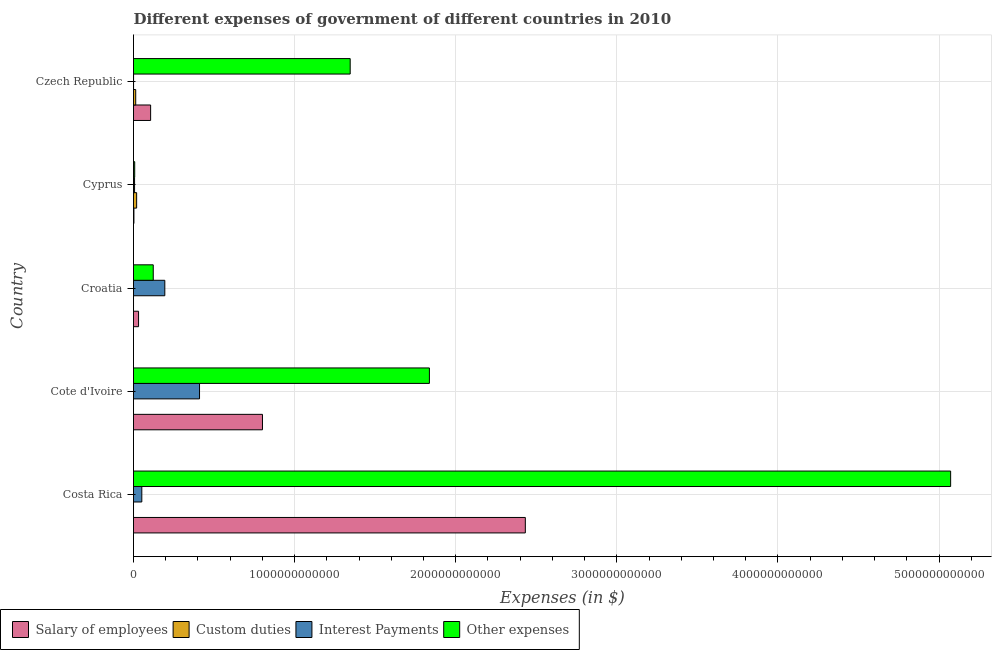How many different coloured bars are there?
Make the answer very short. 4. How many groups of bars are there?
Ensure brevity in your answer.  5. Are the number of bars on each tick of the Y-axis equal?
Give a very brief answer. Yes. How many bars are there on the 2nd tick from the top?
Provide a succinct answer. 4. How many bars are there on the 1st tick from the bottom?
Provide a short and direct response. 4. What is the label of the 4th group of bars from the top?
Provide a succinct answer. Cote d'Ivoire. What is the amount spent on interest payments in Cote d'Ivoire?
Ensure brevity in your answer.  4.10e+11. Across all countries, what is the maximum amount spent on other expenses?
Your answer should be very brief. 5.07e+12. Across all countries, what is the minimum amount spent on salary of employees?
Give a very brief answer. 2.62e+09. In which country was the amount spent on interest payments maximum?
Offer a very short reply. Cote d'Ivoire. In which country was the amount spent on other expenses minimum?
Give a very brief answer. Cyprus. What is the total amount spent on custom duties in the graph?
Your response must be concise. 3.33e+1. What is the difference between the amount spent on custom duties in Cote d'Ivoire and that in Croatia?
Provide a succinct answer. -4.22e+07. What is the difference between the amount spent on salary of employees in Czech Republic and the amount spent on interest payments in Croatia?
Ensure brevity in your answer.  -8.81e+1. What is the average amount spent on salary of employees per country?
Keep it short and to the point. 6.75e+11. What is the difference between the amount spent on custom duties and amount spent on interest payments in Cote d'Ivoire?
Ensure brevity in your answer.  -4.10e+11. What is the ratio of the amount spent on interest payments in Cote d'Ivoire to that in Czech Republic?
Your answer should be compact. 1133.54. Is the difference between the amount spent on custom duties in Cote d'Ivoire and Cyprus greater than the difference between the amount spent on salary of employees in Cote d'Ivoire and Cyprus?
Provide a succinct answer. No. What is the difference between the highest and the second highest amount spent on other expenses?
Make the answer very short. 3.24e+12. What is the difference between the highest and the lowest amount spent on custom duties?
Ensure brevity in your answer.  1.95e+1. In how many countries, is the amount spent on other expenses greater than the average amount spent on other expenses taken over all countries?
Provide a short and direct response. 2. What does the 1st bar from the top in Cyprus represents?
Ensure brevity in your answer.  Other expenses. What does the 2nd bar from the bottom in Czech Republic represents?
Ensure brevity in your answer.  Custom duties. Is it the case that in every country, the sum of the amount spent on salary of employees and amount spent on custom duties is greater than the amount spent on interest payments?
Provide a succinct answer. No. How many bars are there?
Keep it short and to the point. 20. How many countries are there in the graph?
Provide a short and direct response. 5. What is the difference between two consecutive major ticks on the X-axis?
Offer a terse response. 1.00e+12. Does the graph contain any zero values?
Provide a succinct answer. No. Does the graph contain grids?
Keep it short and to the point. Yes. How many legend labels are there?
Offer a terse response. 4. How are the legend labels stacked?
Ensure brevity in your answer.  Horizontal. What is the title of the graph?
Keep it short and to the point. Different expenses of government of different countries in 2010. What is the label or title of the X-axis?
Offer a terse response. Expenses (in $). What is the label or title of the Y-axis?
Your response must be concise. Country. What is the Expenses (in $) in Salary of employees in Costa Rica?
Offer a very short reply. 2.43e+12. What is the Expenses (in $) in Custom duties in Costa Rica?
Make the answer very short. 3.64e+07. What is the Expenses (in $) in Interest Payments in Costa Rica?
Give a very brief answer. 5.15e+1. What is the Expenses (in $) in Other expenses in Costa Rica?
Your answer should be very brief. 5.07e+12. What is the Expenses (in $) in Salary of employees in Cote d'Ivoire?
Offer a very short reply. 8.00e+11. What is the Expenses (in $) in Custom duties in Cote d'Ivoire?
Keep it short and to the point. 1.30e+07. What is the Expenses (in $) in Interest Payments in Cote d'Ivoire?
Provide a succinct answer. 4.10e+11. What is the Expenses (in $) in Other expenses in Cote d'Ivoire?
Give a very brief answer. 1.84e+12. What is the Expenses (in $) of Salary of employees in Croatia?
Provide a succinct answer. 3.14e+1. What is the Expenses (in $) of Custom duties in Croatia?
Your answer should be very brief. 5.52e+07. What is the Expenses (in $) in Interest Payments in Croatia?
Ensure brevity in your answer.  1.94e+11. What is the Expenses (in $) in Other expenses in Croatia?
Offer a very short reply. 1.23e+11. What is the Expenses (in $) in Salary of employees in Cyprus?
Your answer should be compact. 2.62e+09. What is the Expenses (in $) in Custom duties in Cyprus?
Keep it short and to the point. 1.95e+1. What is the Expenses (in $) in Interest Payments in Cyprus?
Provide a succinct answer. 6.55e+09. What is the Expenses (in $) in Other expenses in Cyprus?
Keep it short and to the point. 7.41e+09. What is the Expenses (in $) in Salary of employees in Czech Republic?
Your answer should be very brief. 1.06e+11. What is the Expenses (in $) of Custom duties in Czech Republic?
Keep it short and to the point. 1.37e+1. What is the Expenses (in $) in Interest Payments in Czech Republic?
Ensure brevity in your answer.  3.62e+08. What is the Expenses (in $) of Other expenses in Czech Republic?
Offer a very short reply. 1.34e+12. Across all countries, what is the maximum Expenses (in $) in Salary of employees?
Keep it short and to the point. 2.43e+12. Across all countries, what is the maximum Expenses (in $) of Custom duties?
Your answer should be compact. 1.95e+1. Across all countries, what is the maximum Expenses (in $) of Interest Payments?
Keep it short and to the point. 4.10e+11. Across all countries, what is the maximum Expenses (in $) of Other expenses?
Keep it short and to the point. 5.07e+12. Across all countries, what is the minimum Expenses (in $) in Salary of employees?
Your response must be concise. 2.62e+09. Across all countries, what is the minimum Expenses (in $) in Custom duties?
Offer a terse response. 1.30e+07. Across all countries, what is the minimum Expenses (in $) of Interest Payments?
Your answer should be very brief. 3.62e+08. Across all countries, what is the minimum Expenses (in $) of Other expenses?
Make the answer very short. 7.41e+09. What is the total Expenses (in $) of Salary of employees in the graph?
Give a very brief answer. 3.37e+12. What is the total Expenses (in $) in Custom duties in the graph?
Offer a terse response. 3.33e+1. What is the total Expenses (in $) in Interest Payments in the graph?
Ensure brevity in your answer.  6.63e+11. What is the total Expenses (in $) of Other expenses in the graph?
Offer a terse response. 8.38e+12. What is the difference between the Expenses (in $) in Salary of employees in Costa Rica and that in Cote d'Ivoire?
Give a very brief answer. 1.63e+12. What is the difference between the Expenses (in $) in Custom duties in Costa Rica and that in Cote d'Ivoire?
Your response must be concise. 2.34e+07. What is the difference between the Expenses (in $) in Interest Payments in Costa Rica and that in Cote d'Ivoire?
Your answer should be compact. -3.58e+11. What is the difference between the Expenses (in $) in Other expenses in Costa Rica and that in Cote d'Ivoire?
Your answer should be compact. 3.24e+12. What is the difference between the Expenses (in $) in Salary of employees in Costa Rica and that in Croatia?
Make the answer very short. 2.40e+12. What is the difference between the Expenses (in $) of Custom duties in Costa Rica and that in Croatia?
Make the answer very short. -1.88e+07. What is the difference between the Expenses (in $) of Interest Payments in Costa Rica and that in Croatia?
Your response must be concise. -1.43e+11. What is the difference between the Expenses (in $) of Other expenses in Costa Rica and that in Croatia?
Provide a short and direct response. 4.95e+12. What is the difference between the Expenses (in $) in Salary of employees in Costa Rica and that in Cyprus?
Offer a terse response. 2.43e+12. What is the difference between the Expenses (in $) of Custom duties in Costa Rica and that in Cyprus?
Your answer should be very brief. -1.95e+1. What is the difference between the Expenses (in $) in Interest Payments in Costa Rica and that in Cyprus?
Offer a terse response. 4.50e+1. What is the difference between the Expenses (in $) of Other expenses in Costa Rica and that in Cyprus?
Offer a terse response. 5.06e+12. What is the difference between the Expenses (in $) of Salary of employees in Costa Rica and that in Czech Republic?
Your answer should be compact. 2.33e+12. What is the difference between the Expenses (in $) of Custom duties in Costa Rica and that in Czech Republic?
Give a very brief answer. -1.37e+1. What is the difference between the Expenses (in $) in Interest Payments in Costa Rica and that in Czech Republic?
Offer a terse response. 5.12e+1. What is the difference between the Expenses (in $) of Other expenses in Costa Rica and that in Czech Republic?
Your answer should be compact. 3.73e+12. What is the difference between the Expenses (in $) in Salary of employees in Cote d'Ivoire and that in Croatia?
Give a very brief answer. 7.69e+11. What is the difference between the Expenses (in $) of Custom duties in Cote d'Ivoire and that in Croatia?
Keep it short and to the point. -4.22e+07. What is the difference between the Expenses (in $) of Interest Payments in Cote d'Ivoire and that in Croatia?
Your response must be concise. 2.15e+11. What is the difference between the Expenses (in $) of Other expenses in Cote d'Ivoire and that in Croatia?
Give a very brief answer. 1.71e+12. What is the difference between the Expenses (in $) of Salary of employees in Cote d'Ivoire and that in Cyprus?
Provide a succinct answer. 7.98e+11. What is the difference between the Expenses (in $) of Custom duties in Cote d'Ivoire and that in Cyprus?
Your response must be concise. -1.95e+1. What is the difference between the Expenses (in $) of Interest Payments in Cote d'Ivoire and that in Cyprus?
Provide a succinct answer. 4.03e+11. What is the difference between the Expenses (in $) of Other expenses in Cote d'Ivoire and that in Cyprus?
Ensure brevity in your answer.  1.83e+12. What is the difference between the Expenses (in $) of Salary of employees in Cote d'Ivoire and that in Czech Republic?
Your response must be concise. 6.94e+11. What is the difference between the Expenses (in $) of Custom duties in Cote d'Ivoire and that in Czech Republic?
Your answer should be very brief. -1.37e+1. What is the difference between the Expenses (in $) of Interest Payments in Cote d'Ivoire and that in Czech Republic?
Provide a succinct answer. 4.09e+11. What is the difference between the Expenses (in $) in Other expenses in Cote d'Ivoire and that in Czech Republic?
Keep it short and to the point. 4.92e+11. What is the difference between the Expenses (in $) of Salary of employees in Croatia and that in Cyprus?
Offer a terse response. 2.87e+1. What is the difference between the Expenses (in $) of Custom duties in Croatia and that in Cyprus?
Offer a terse response. -1.94e+1. What is the difference between the Expenses (in $) of Interest Payments in Croatia and that in Cyprus?
Make the answer very short. 1.88e+11. What is the difference between the Expenses (in $) in Other expenses in Croatia and that in Cyprus?
Make the answer very short. 1.15e+11. What is the difference between the Expenses (in $) of Salary of employees in Croatia and that in Czech Republic?
Offer a very short reply. -7.49e+1. What is the difference between the Expenses (in $) of Custom duties in Croatia and that in Czech Republic?
Provide a succinct answer. -1.37e+1. What is the difference between the Expenses (in $) of Interest Payments in Croatia and that in Czech Republic?
Provide a succinct answer. 1.94e+11. What is the difference between the Expenses (in $) of Other expenses in Croatia and that in Czech Republic?
Ensure brevity in your answer.  -1.22e+12. What is the difference between the Expenses (in $) in Salary of employees in Cyprus and that in Czech Republic?
Provide a short and direct response. -1.04e+11. What is the difference between the Expenses (in $) in Custom duties in Cyprus and that in Czech Republic?
Your answer should be compact. 5.76e+09. What is the difference between the Expenses (in $) of Interest Payments in Cyprus and that in Czech Republic?
Your response must be concise. 6.19e+09. What is the difference between the Expenses (in $) of Other expenses in Cyprus and that in Czech Republic?
Keep it short and to the point. -1.34e+12. What is the difference between the Expenses (in $) of Salary of employees in Costa Rica and the Expenses (in $) of Custom duties in Cote d'Ivoire?
Offer a very short reply. 2.43e+12. What is the difference between the Expenses (in $) in Salary of employees in Costa Rica and the Expenses (in $) in Interest Payments in Cote d'Ivoire?
Your answer should be very brief. 2.02e+12. What is the difference between the Expenses (in $) of Salary of employees in Costa Rica and the Expenses (in $) of Other expenses in Cote d'Ivoire?
Your answer should be compact. 5.95e+11. What is the difference between the Expenses (in $) in Custom duties in Costa Rica and the Expenses (in $) in Interest Payments in Cote d'Ivoire?
Make the answer very short. -4.10e+11. What is the difference between the Expenses (in $) of Custom duties in Costa Rica and the Expenses (in $) of Other expenses in Cote d'Ivoire?
Keep it short and to the point. -1.84e+12. What is the difference between the Expenses (in $) of Interest Payments in Costa Rica and the Expenses (in $) of Other expenses in Cote d'Ivoire?
Your answer should be compact. -1.79e+12. What is the difference between the Expenses (in $) in Salary of employees in Costa Rica and the Expenses (in $) in Custom duties in Croatia?
Keep it short and to the point. 2.43e+12. What is the difference between the Expenses (in $) in Salary of employees in Costa Rica and the Expenses (in $) in Interest Payments in Croatia?
Offer a very short reply. 2.24e+12. What is the difference between the Expenses (in $) in Salary of employees in Costa Rica and the Expenses (in $) in Other expenses in Croatia?
Ensure brevity in your answer.  2.31e+12. What is the difference between the Expenses (in $) in Custom duties in Costa Rica and the Expenses (in $) in Interest Payments in Croatia?
Your response must be concise. -1.94e+11. What is the difference between the Expenses (in $) of Custom duties in Costa Rica and the Expenses (in $) of Other expenses in Croatia?
Keep it short and to the point. -1.23e+11. What is the difference between the Expenses (in $) in Interest Payments in Costa Rica and the Expenses (in $) in Other expenses in Croatia?
Your answer should be compact. -7.11e+1. What is the difference between the Expenses (in $) in Salary of employees in Costa Rica and the Expenses (in $) in Custom duties in Cyprus?
Make the answer very short. 2.41e+12. What is the difference between the Expenses (in $) of Salary of employees in Costa Rica and the Expenses (in $) of Interest Payments in Cyprus?
Offer a terse response. 2.43e+12. What is the difference between the Expenses (in $) of Salary of employees in Costa Rica and the Expenses (in $) of Other expenses in Cyprus?
Provide a succinct answer. 2.42e+12. What is the difference between the Expenses (in $) of Custom duties in Costa Rica and the Expenses (in $) of Interest Payments in Cyprus?
Ensure brevity in your answer.  -6.52e+09. What is the difference between the Expenses (in $) of Custom duties in Costa Rica and the Expenses (in $) of Other expenses in Cyprus?
Your response must be concise. -7.37e+09. What is the difference between the Expenses (in $) of Interest Payments in Costa Rica and the Expenses (in $) of Other expenses in Cyprus?
Make the answer very short. 4.41e+1. What is the difference between the Expenses (in $) of Salary of employees in Costa Rica and the Expenses (in $) of Custom duties in Czech Republic?
Your answer should be very brief. 2.42e+12. What is the difference between the Expenses (in $) in Salary of employees in Costa Rica and the Expenses (in $) in Interest Payments in Czech Republic?
Your response must be concise. 2.43e+12. What is the difference between the Expenses (in $) in Salary of employees in Costa Rica and the Expenses (in $) in Other expenses in Czech Republic?
Your answer should be compact. 1.09e+12. What is the difference between the Expenses (in $) of Custom duties in Costa Rica and the Expenses (in $) of Interest Payments in Czech Republic?
Keep it short and to the point. -3.25e+08. What is the difference between the Expenses (in $) in Custom duties in Costa Rica and the Expenses (in $) in Other expenses in Czech Republic?
Ensure brevity in your answer.  -1.34e+12. What is the difference between the Expenses (in $) in Interest Payments in Costa Rica and the Expenses (in $) in Other expenses in Czech Republic?
Make the answer very short. -1.29e+12. What is the difference between the Expenses (in $) in Salary of employees in Cote d'Ivoire and the Expenses (in $) in Custom duties in Croatia?
Ensure brevity in your answer.  8.00e+11. What is the difference between the Expenses (in $) of Salary of employees in Cote d'Ivoire and the Expenses (in $) of Interest Payments in Croatia?
Your answer should be compact. 6.06e+11. What is the difference between the Expenses (in $) of Salary of employees in Cote d'Ivoire and the Expenses (in $) of Other expenses in Croatia?
Keep it short and to the point. 6.78e+11. What is the difference between the Expenses (in $) in Custom duties in Cote d'Ivoire and the Expenses (in $) in Interest Payments in Croatia?
Make the answer very short. -1.94e+11. What is the difference between the Expenses (in $) of Custom duties in Cote d'Ivoire and the Expenses (in $) of Other expenses in Croatia?
Provide a succinct answer. -1.23e+11. What is the difference between the Expenses (in $) of Interest Payments in Cote d'Ivoire and the Expenses (in $) of Other expenses in Croatia?
Your answer should be compact. 2.87e+11. What is the difference between the Expenses (in $) of Salary of employees in Cote d'Ivoire and the Expenses (in $) of Custom duties in Cyprus?
Your response must be concise. 7.81e+11. What is the difference between the Expenses (in $) in Salary of employees in Cote d'Ivoire and the Expenses (in $) in Interest Payments in Cyprus?
Ensure brevity in your answer.  7.94e+11. What is the difference between the Expenses (in $) of Salary of employees in Cote d'Ivoire and the Expenses (in $) of Other expenses in Cyprus?
Your answer should be compact. 7.93e+11. What is the difference between the Expenses (in $) in Custom duties in Cote d'Ivoire and the Expenses (in $) in Interest Payments in Cyprus?
Offer a terse response. -6.54e+09. What is the difference between the Expenses (in $) of Custom duties in Cote d'Ivoire and the Expenses (in $) of Other expenses in Cyprus?
Keep it short and to the point. -7.40e+09. What is the difference between the Expenses (in $) of Interest Payments in Cote d'Ivoire and the Expenses (in $) of Other expenses in Cyprus?
Your answer should be very brief. 4.02e+11. What is the difference between the Expenses (in $) of Salary of employees in Cote d'Ivoire and the Expenses (in $) of Custom duties in Czech Republic?
Your answer should be very brief. 7.87e+11. What is the difference between the Expenses (in $) of Salary of employees in Cote d'Ivoire and the Expenses (in $) of Interest Payments in Czech Republic?
Offer a very short reply. 8.00e+11. What is the difference between the Expenses (in $) in Salary of employees in Cote d'Ivoire and the Expenses (in $) in Other expenses in Czech Republic?
Give a very brief answer. -5.45e+11. What is the difference between the Expenses (in $) in Custom duties in Cote d'Ivoire and the Expenses (in $) in Interest Payments in Czech Republic?
Offer a very short reply. -3.48e+08. What is the difference between the Expenses (in $) in Custom duties in Cote d'Ivoire and the Expenses (in $) in Other expenses in Czech Republic?
Offer a very short reply. -1.34e+12. What is the difference between the Expenses (in $) in Interest Payments in Cote d'Ivoire and the Expenses (in $) in Other expenses in Czech Republic?
Ensure brevity in your answer.  -9.35e+11. What is the difference between the Expenses (in $) of Salary of employees in Croatia and the Expenses (in $) of Custom duties in Cyprus?
Make the answer very short. 1.19e+1. What is the difference between the Expenses (in $) of Salary of employees in Croatia and the Expenses (in $) of Interest Payments in Cyprus?
Give a very brief answer. 2.48e+1. What is the difference between the Expenses (in $) of Salary of employees in Croatia and the Expenses (in $) of Other expenses in Cyprus?
Provide a short and direct response. 2.40e+1. What is the difference between the Expenses (in $) of Custom duties in Croatia and the Expenses (in $) of Interest Payments in Cyprus?
Your answer should be very brief. -6.50e+09. What is the difference between the Expenses (in $) in Custom duties in Croatia and the Expenses (in $) in Other expenses in Cyprus?
Provide a succinct answer. -7.35e+09. What is the difference between the Expenses (in $) of Interest Payments in Croatia and the Expenses (in $) of Other expenses in Cyprus?
Your answer should be compact. 1.87e+11. What is the difference between the Expenses (in $) of Salary of employees in Croatia and the Expenses (in $) of Custom duties in Czech Republic?
Keep it short and to the point. 1.76e+1. What is the difference between the Expenses (in $) of Salary of employees in Croatia and the Expenses (in $) of Interest Payments in Czech Republic?
Offer a very short reply. 3.10e+1. What is the difference between the Expenses (in $) in Salary of employees in Croatia and the Expenses (in $) in Other expenses in Czech Republic?
Give a very brief answer. -1.31e+12. What is the difference between the Expenses (in $) in Custom duties in Croatia and the Expenses (in $) in Interest Payments in Czech Republic?
Offer a terse response. -3.06e+08. What is the difference between the Expenses (in $) in Custom duties in Croatia and the Expenses (in $) in Other expenses in Czech Republic?
Provide a short and direct response. -1.34e+12. What is the difference between the Expenses (in $) of Interest Payments in Croatia and the Expenses (in $) of Other expenses in Czech Republic?
Provide a succinct answer. -1.15e+12. What is the difference between the Expenses (in $) in Salary of employees in Cyprus and the Expenses (in $) in Custom duties in Czech Republic?
Offer a terse response. -1.11e+1. What is the difference between the Expenses (in $) in Salary of employees in Cyprus and the Expenses (in $) in Interest Payments in Czech Republic?
Make the answer very short. 2.26e+09. What is the difference between the Expenses (in $) in Salary of employees in Cyprus and the Expenses (in $) in Other expenses in Czech Republic?
Your response must be concise. -1.34e+12. What is the difference between the Expenses (in $) in Custom duties in Cyprus and the Expenses (in $) in Interest Payments in Czech Republic?
Keep it short and to the point. 1.91e+1. What is the difference between the Expenses (in $) of Custom duties in Cyprus and the Expenses (in $) of Other expenses in Czech Republic?
Offer a terse response. -1.33e+12. What is the difference between the Expenses (in $) in Interest Payments in Cyprus and the Expenses (in $) in Other expenses in Czech Republic?
Offer a very short reply. -1.34e+12. What is the average Expenses (in $) in Salary of employees per country?
Offer a very short reply. 6.75e+11. What is the average Expenses (in $) in Custom duties per country?
Provide a succinct answer. 6.67e+09. What is the average Expenses (in $) of Interest Payments per country?
Provide a succinct answer. 1.33e+11. What is the average Expenses (in $) of Other expenses per country?
Provide a succinct answer. 1.68e+12. What is the difference between the Expenses (in $) of Salary of employees and Expenses (in $) of Custom duties in Costa Rica?
Give a very brief answer. 2.43e+12. What is the difference between the Expenses (in $) in Salary of employees and Expenses (in $) in Interest Payments in Costa Rica?
Your answer should be very brief. 2.38e+12. What is the difference between the Expenses (in $) in Salary of employees and Expenses (in $) in Other expenses in Costa Rica?
Offer a terse response. -2.64e+12. What is the difference between the Expenses (in $) in Custom duties and Expenses (in $) in Interest Payments in Costa Rica?
Keep it short and to the point. -5.15e+1. What is the difference between the Expenses (in $) in Custom duties and Expenses (in $) in Other expenses in Costa Rica?
Ensure brevity in your answer.  -5.07e+12. What is the difference between the Expenses (in $) of Interest Payments and Expenses (in $) of Other expenses in Costa Rica?
Make the answer very short. -5.02e+12. What is the difference between the Expenses (in $) of Salary of employees and Expenses (in $) of Custom duties in Cote d'Ivoire?
Make the answer very short. 8.00e+11. What is the difference between the Expenses (in $) in Salary of employees and Expenses (in $) in Interest Payments in Cote d'Ivoire?
Your response must be concise. 3.91e+11. What is the difference between the Expenses (in $) in Salary of employees and Expenses (in $) in Other expenses in Cote d'Ivoire?
Offer a very short reply. -1.04e+12. What is the difference between the Expenses (in $) of Custom duties and Expenses (in $) of Interest Payments in Cote d'Ivoire?
Your answer should be very brief. -4.10e+11. What is the difference between the Expenses (in $) of Custom duties and Expenses (in $) of Other expenses in Cote d'Ivoire?
Your answer should be very brief. -1.84e+12. What is the difference between the Expenses (in $) in Interest Payments and Expenses (in $) in Other expenses in Cote d'Ivoire?
Give a very brief answer. -1.43e+12. What is the difference between the Expenses (in $) of Salary of employees and Expenses (in $) of Custom duties in Croatia?
Offer a very short reply. 3.13e+1. What is the difference between the Expenses (in $) in Salary of employees and Expenses (in $) in Interest Payments in Croatia?
Give a very brief answer. -1.63e+11. What is the difference between the Expenses (in $) of Salary of employees and Expenses (in $) of Other expenses in Croatia?
Keep it short and to the point. -9.12e+1. What is the difference between the Expenses (in $) of Custom duties and Expenses (in $) of Interest Payments in Croatia?
Provide a short and direct response. -1.94e+11. What is the difference between the Expenses (in $) of Custom duties and Expenses (in $) of Other expenses in Croatia?
Keep it short and to the point. -1.23e+11. What is the difference between the Expenses (in $) in Interest Payments and Expenses (in $) in Other expenses in Croatia?
Your answer should be very brief. 7.17e+1. What is the difference between the Expenses (in $) of Salary of employees and Expenses (in $) of Custom duties in Cyprus?
Offer a very short reply. -1.69e+1. What is the difference between the Expenses (in $) of Salary of employees and Expenses (in $) of Interest Payments in Cyprus?
Offer a very short reply. -3.93e+09. What is the difference between the Expenses (in $) in Salary of employees and Expenses (in $) in Other expenses in Cyprus?
Provide a short and direct response. -4.79e+09. What is the difference between the Expenses (in $) of Custom duties and Expenses (in $) of Interest Payments in Cyprus?
Give a very brief answer. 1.29e+1. What is the difference between the Expenses (in $) of Custom duties and Expenses (in $) of Other expenses in Cyprus?
Your response must be concise. 1.21e+1. What is the difference between the Expenses (in $) of Interest Payments and Expenses (in $) of Other expenses in Cyprus?
Offer a terse response. -8.58e+08. What is the difference between the Expenses (in $) of Salary of employees and Expenses (in $) of Custom duties in Czech Republic?
Your answer should be compact. 9.25e+1. What is the difference between the Expenses (in $) in Salary of employees and Expenses (in $) in Interest Payments in Czech Republic?
Provide a succinct answer. 1.06e+11. What is the difference between the Expenses (in $) in Salary of employees and Expenses (in $) in Other expenses in Czech Republic?
Ensure brevity in your answer.  -1.24e+12. What is the difference between the Expenses (in $) of Custom duties and Expenses (in $) of Interest Payments in Czech Republic?
Keep it short and to the point. 1.34e+1. What is the difference between the Expenses (in $) in Custom duties and Expenses (in $) in Other expenses in Czech Republic?
Give a very brief answer. -1.33e+12. What is the difference between the Expenses (in $) in Interest Payments and Expenses (in $) in Other expenses in Czech Republic?
Offer a very short reply. -1.34e+12. What is the ratio of the Expenses (in $) in Salary of employees in Costa Rica to that in Cote d'Ivoire?
Provide a succinct answer. 3.04. What is the ratio of the Expenses (in $) of Interest Payments in Costa Rica to that in Cote d'Ivoire?
Give a very brief answer. 0.13. What is the ratio of the Expenses (in $) of Other expenses in Costa Rica to that in Cote d'Ivoire?
Offer a terse response. 2.76. What is the ratio of the Expenses (in $) of Salary of employees in Costa Rica to that in Croatia?
Your response must be concise. 77.52. What is the ratio of the Expenses (in $) in Custom duties in Costa Rica to that in Croatia?
Provide a short and direct response. 0.66. What is the ratio of the Expenses (in $) in Interest Payments in Costa Rica to that in Croatia?
Your answer should be compact. 0.27. What is the ratio of the Expenses (in $) of Other expenses in Costa Rica to that in Croatia?
Your response must be concise. 41.38. What is the ratio of the Expenses (in $) of Salary of employees in Costa Rica to that in Cyprus?
Ensure brevity in your answer.  927.66. What is the ratio of the Expenses (in $) of Custom duties in Costa Rica to that in Cyprus?
Provide a succinct answer. 0. What is the ratio of the Expenses (in $) of Interest Payments in Costa Rica to that in Cyprus?
Ensure brevity in your answer.  7.86. What is the ratio of the Expenses (in $) of Other expenses in Costa Rica to that in Cyprus?
Keep it short and to the point. 684.51. What is the ratio of the Expenses (in $) in Salary of employees in Costa Rica to that in Czech Republic?
Offer a terse response. 22.89. What is the ratio of the Expenses (in $) of Custom duties in Costa Rica to that in Czech Republic?
Keep it short and to the point. 0. What is the ratio of the Expenses (in $) in Interest Payments in Costa Rica to that in Czech Republic?
Ensure brevity in your answer.  142.5. What is the ratio of the Expenses (in $) in Other expenses in Costa Rica to that in Czech Republic?
Your answer should be very brief. 3.77. What is the ratio of the Expenses (in $) of Salary of employees in Cote d'Ivoire to that in Croatia?
Ensure brevity in your answer.  25.52. What is the ratio of the Expenses (in $) of Custom duties in Cote d'Ivoire to that in Croatia?
Make the answer very short. 0.24. What is the ratio of the Expenses (in $) in Interest Payments in Cote d'Ivoire to that in Croatia?
Give a very brief answer. 2.11. What is the ratio of the Expenses (in $) in Other expenses in Cote d'Ivoire to that in Croatia?
Your response must be concise. 14.98. What is the ratio of the Expenses (in $) of Salary of employees in Cote d'Ivoire to that in Cyprus?
Offer a very short reply. 305.33. What is the ratio of the Expenses (in $) of Custom duties in Cote d'Ivoire to that in Cyprus?
Offer a very short reply. 0. What is the ratio of the Expenses (in $) of Interest Payments in Cote d'Ivoire to that in Cyprus?
Make the answer very short. 62.54. What is the ratio of the Expenses (in $) of Other expenses in Cote d'Ivoire to that in Cyprus?
Your response must be concise. 247.88. What is the ratio of the Expenses (in $) of Salary of employees in Cote d'Ivoire to that in Czech Republic?
Give a very brief answer. 7.53. What is the ratio of the Expenses (in $) of Custom duties in Cote d'Ivoire to that in Czech Republic?
Offer a terse response. 0. What is the ratio of the Expenses (in $) of Interest Payments in Cote d'Ivoire to that in Czech Republic?
Ensure brevity in your answer.  1133.54. What is the ratio of the Expenses (in $) of Other expenses in Cote d'Ivoire to that in Czech Republic?
Ensure brevity in your answer.  1.37. What is the ratio of the Expenses (in $) in Salary of employees in Croatia to that in Cyprus?
Offer a very short reply. 11.97. What is the ratio of the Expenses (in $) of Custom duties in Croatia to that in Cyprus?
Provide a succinct answer. 0. What is the ratio of the Expenses (in $) of Interest Payments in Croatia to that in Cyprus?
Your response must be concise. 29.66. What is the ratio of the Expenses (in $) in Other expenses in Croatia to that in Cyprus?
Ensure brevity in your answer.  16.54. What is the ratio of the Expenses (in $) in Salary of employees in Croatia to that in Czech Republic?
Provide a succinct answer. 0.3. What is the ratio of the Expenses (in $) of Custom duties in Croatia to that in Czech Republic?
Make the answer very short. 0. What is the ratio of the Expenses (in $) in Interest Payments in Croatia to that in Czech Republic?
Your answer should be compact. 537.57. What is the ratio of the Expenses (in $) of Other expenses in Croatia to that in Czech Republic?
Your response must be concise. 0.09. What is the ratio of the Expenses (in $) in Salary of employees in Cyprus to that in Czech Republic?
Keep it short and to the point. 0.02. What is the ratio of the Expenses (in $) in Custom duties in Cyprus to that in Czech Republic?
Offer a terse response. 1.42. What is the ratio of the Expenses (in $) of Interest Payments in Cyprus to that in Czech Republic?
Make the answer very short. 18.12. What is the ratio of the Expenses (in $) in Other expenses in Cyprus to that in Czech Republic?
Make the answer very short. 0.01. What is the difference between the highest and the second highest Expenses (in $) of Salary of employees?
Offer a terse response. 1.63e+12. What is the difference between the highest and the second highest Expenses (in $) in Custom duties?
Offer a very short reply. 5.76e+09. What is the difference between the highest and the second highest Expenses (in $) of Interest Payments?
Your answer should be compact. 2.15e+11. What is the difference between the highest and the second highest Expenses (in $) in Other expenses?
Ensure brevity in your answer.  3.24e+12. What is the difference between the highest and the lowest Expenses (in $) in Salary of employees?
Your answer should be compact. 2.43e+12. What is the difference between the highest and the lowest Expenses (in $) of Custom duties?
Keep it short and to the point. 1.95e+1. What is the difference between the highest and the lowest Expenses (in $) in Interest Payments?
Keep it short and to the point. 4.09e+11. What is the difference between the highest and the lowest Expenses (in $) in Other expenses?
Your answer should be very brief. 5.06e+12. 